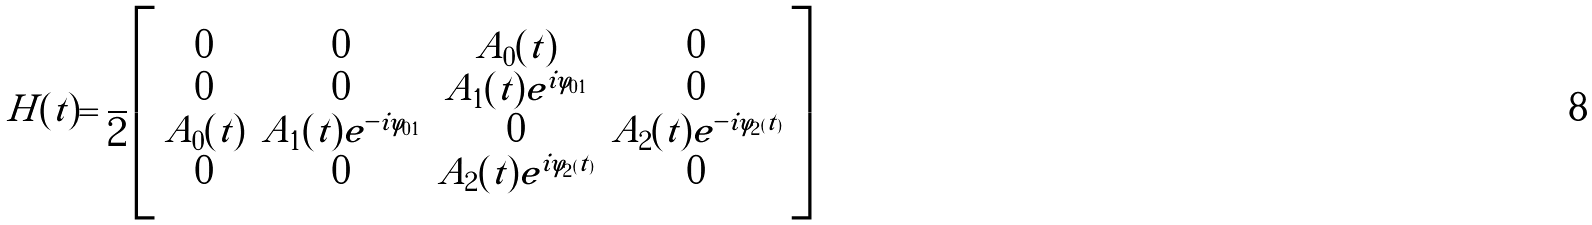<formula> <loc_0><loc_0><loc_500><loc_500>H ( t ) = \frac { } { 2 } \left [ \begin{array} { c c c c } 0 & 0 & A _ { 0 } ( t ) & 0 \\ 0 & 0 & A _ { 1 } ( t ) e ^ { i \varphi _ { 0 1 } } & 0 \\ A _ { 0 } ( t ) & A _ { 1 } ( t ) e ^ { - i \varphi _ { 0 1 } } & 0 & A _ { 2 } ( t ) e ^ { - i \varphi _ { 2 } ( t ) } \\ 0 & 0 & A _ { 2 } ( t ) e ^ { i \varphi _ { 2 } ( t ) } & 0 \\ \end{array} \right ]</formula> 